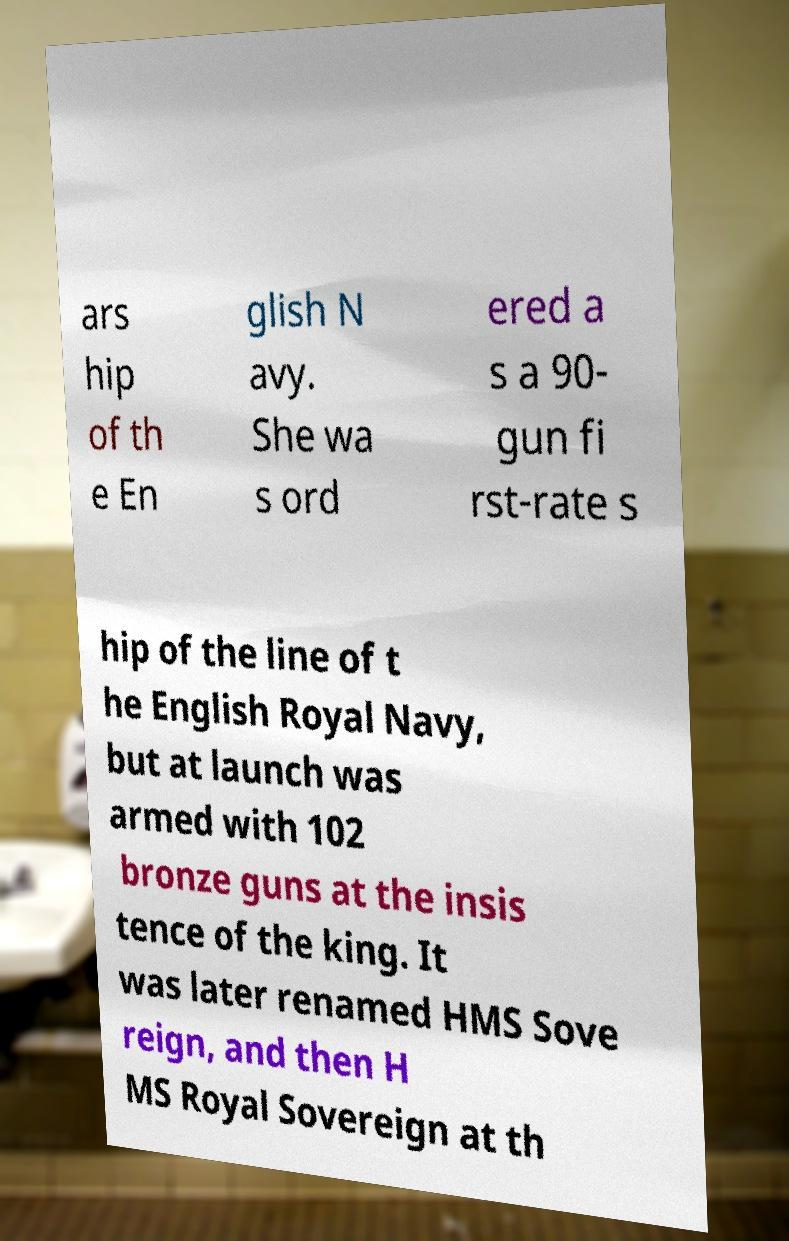For documentation purposes, I need the text within this image transcribed. Could you provide that? ars hip of th e En glish N avy. She wa s ord ered a s a 90- gun fi rst-rate s hip of the line of t he English Royal Navy, but at launch was armed with 102 bronze guns at the insis tence of the king. It was later renamed HMS Sove reign, and then H MS Royal Sovereign at th 